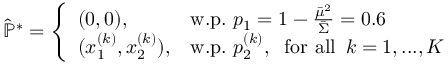<formula> <loc_0><loc_0><loc_500><loc_500>\begin{array} { r } { \hat { \mathbb { P } } ^ { * } = \left \{ \begin{array} { l l } { ( 0 , 0 ) , \, } & { w . p . p _ { 1 } = 1 - \frac { \bar { \mu } ^ { 2 } } { \bar { \Sigma } } = 0 . 6 } \\ { ( x _ { 1 } ^ { ( k ) } , x _ { 2 } ^ { ( k ) } ) , } & { w . p . p _ { 2 } ^ { ( k ) } , \, f o r a l l \, k = 1 , \dots , K } \end{array} } \end{array}</formula> 